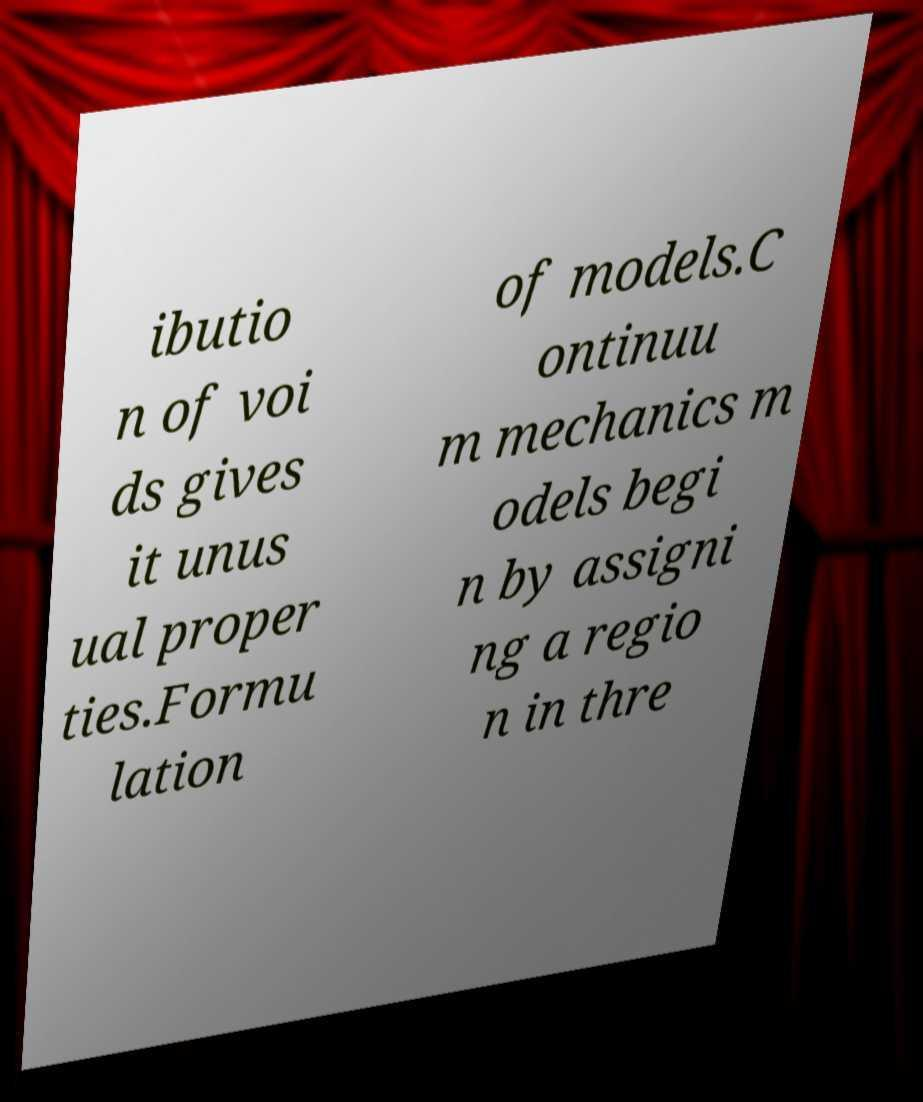I need the written content from this picture converted into text. Can you do that? ibutio n of voi ds gives it unus ual proper ties.Formu lation of models.C ontinuu m mechanics m odels begi n by assigni ng a regio n in thre 